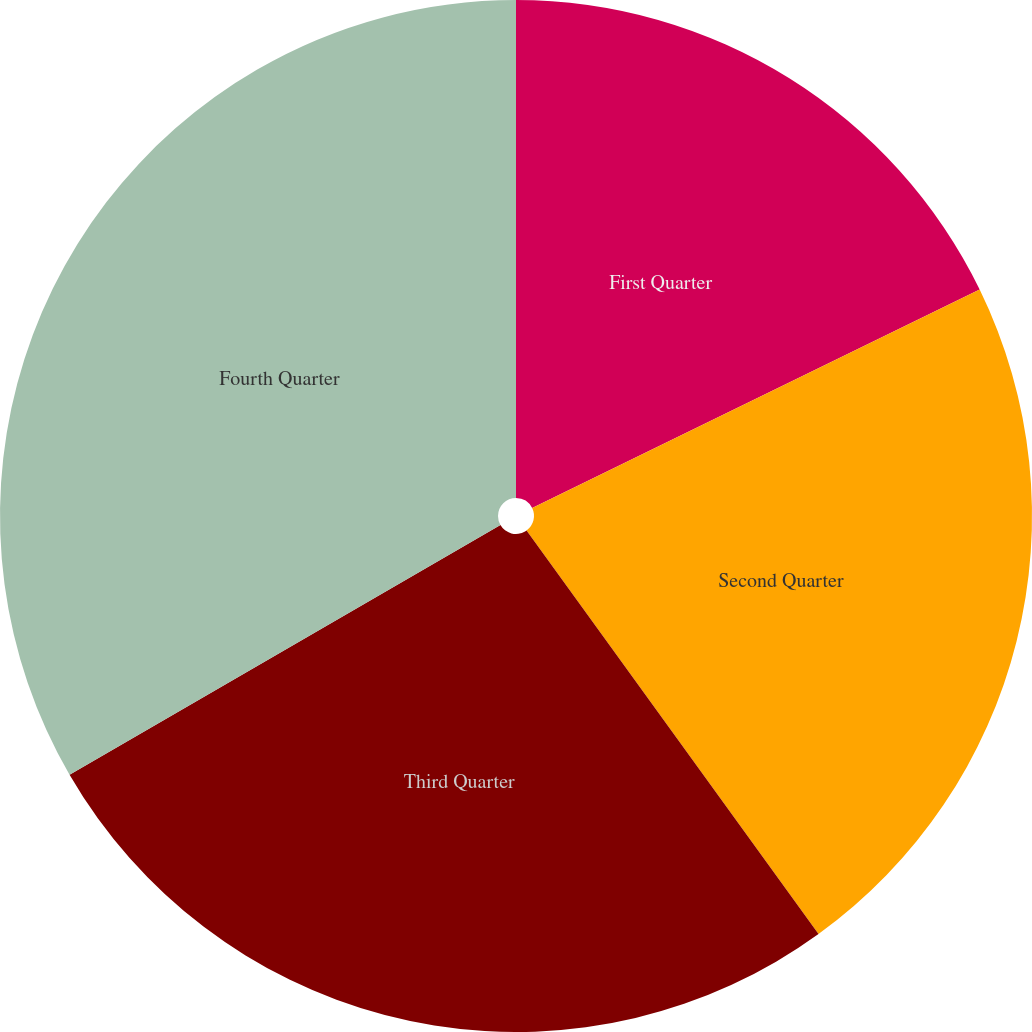Convert chart to OTSL. <chart><loc_0><loc_0><loc_500><loc_500><pie_chart><fcel>First Quarter<fcel>Second Quarter<fcel>Third Quarter<fcel>Fourth Quarter<nl><fcel>17.77%<fcel>22.26%<fcel>26.61%<fcel>33.36%<nl></chart> 